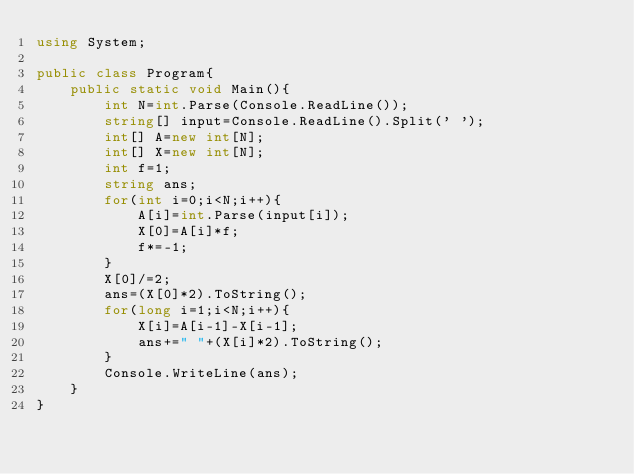<code> <loc_0><loc_0><loc_500><loc_500><_C#_>using System;

public class Program{
    public static void Main(){
        int N=int.Parse(Console.ReadLine());
        string[] input=Console.ReadLine().Split(' ');
        int[] A=new int[N];
        int[] X=new int[N];
        int f=1;
        string ans;
        for(int i=0;i<N;i++){
            A[i]=int.Parse(input[i]);
            X[0]=A[i]*f;
            f*=-1;
        }
        X[0]/=2;
        ans=(X[0]*2).ToString();
        for(long i=1;i<N;i++){
            X[i]=A[i-1]-X[i-1];
            ans+=" "+(X[i]*2).ToString();
        }
        Console.WriteLine(ans);
    }
}
</code> 